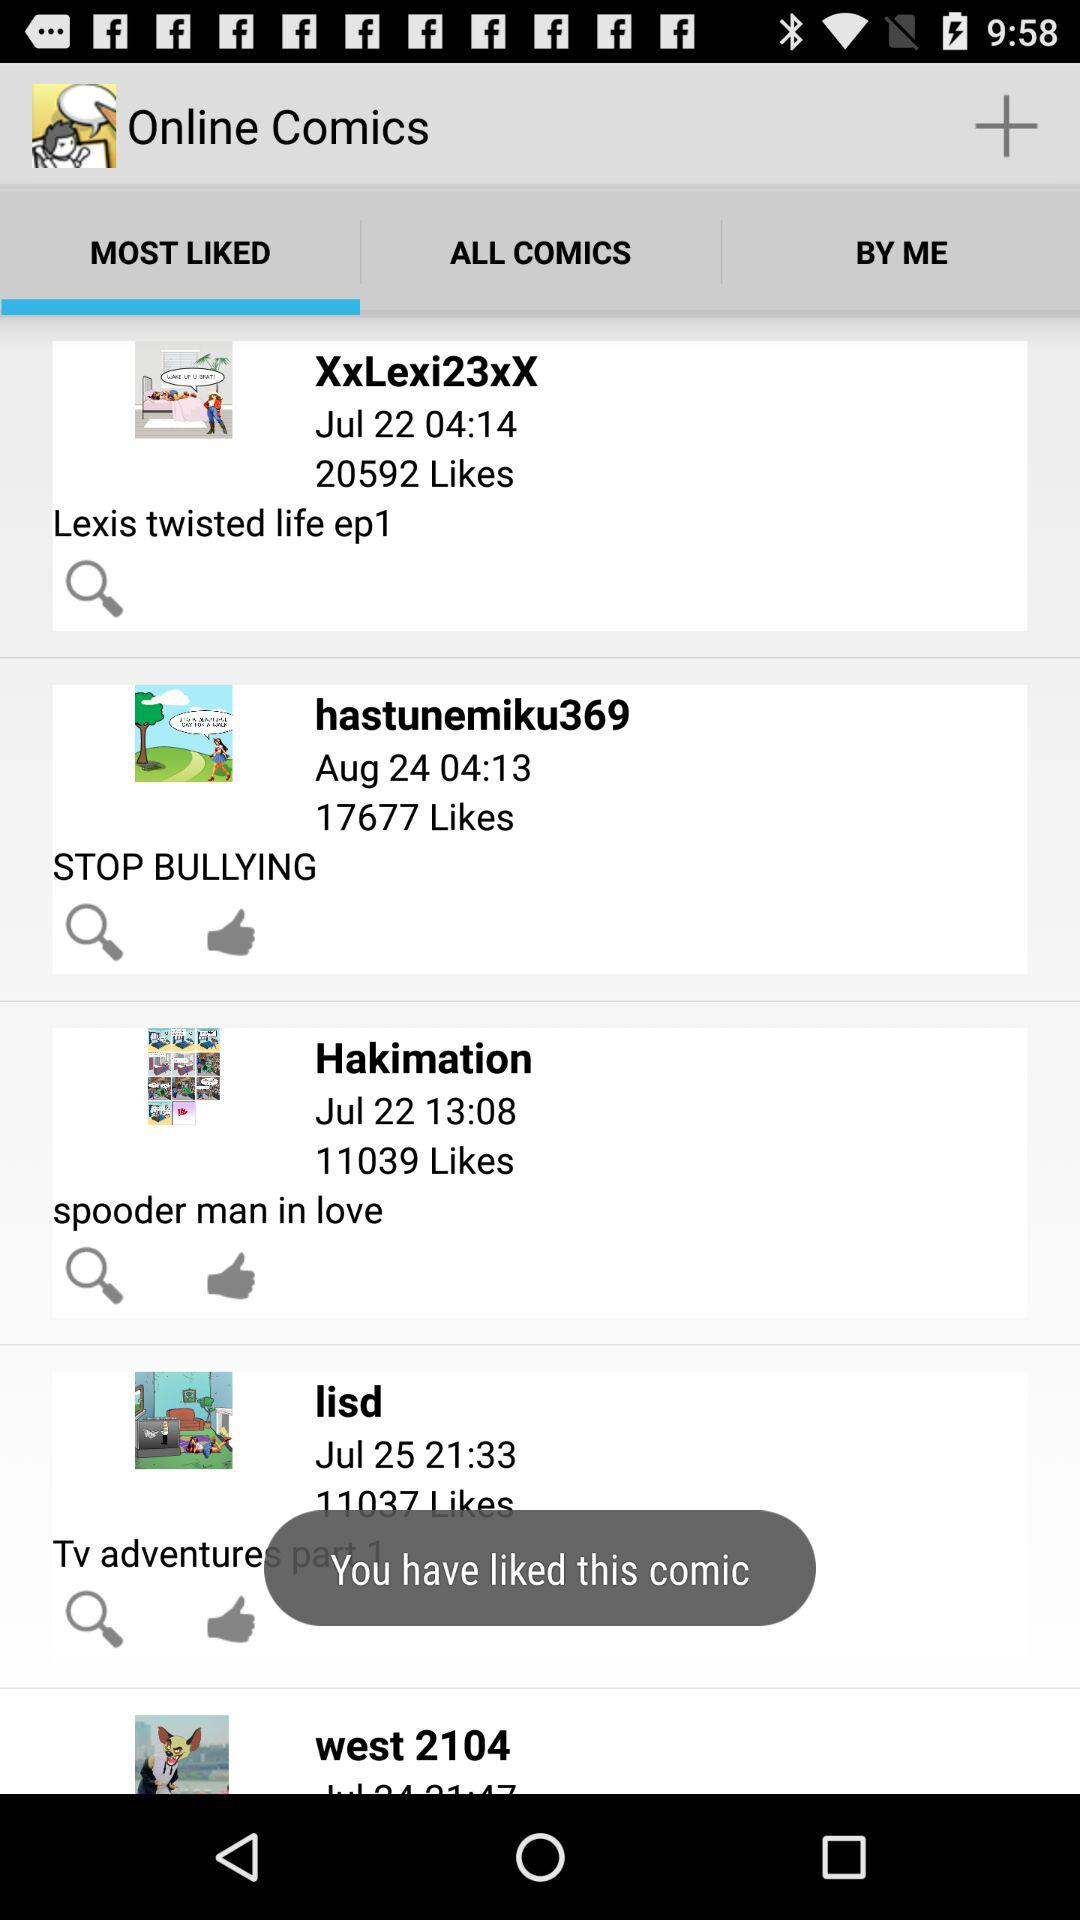What is the star rating of XxLexi23xX?
When the provided information is insufficient, respond with <no answer>. <no answer> 